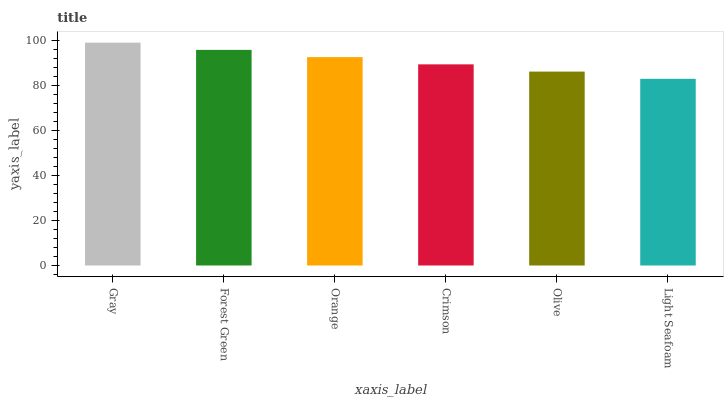Is Light Seafoam the minimum?
Answer yes or no. Yes. Is Gray the maximum?
Answer yes or no. Yes. Is Forest Green the minimum?
Answer yes or no. No. Is Forest Green the maximum?
Answer yes or no. No. Is Gray greater than Forest Green?
Answer yes or no. Yes. Is Forest Green less than Gray?
Answer yes or no. Yes. Is Forest Green greater than Gray?
Answer yes or no. No. Is Gray less than Forest Green?
Answer yes or no. No. Is Orange the high median?
Answer yes or no. Yes. Is Crimson the low median?
Answer yes or no. Yes. Is Gray the high median?
Answer yes or no. No. Is Olive the low median?
Answer yes or no. No. 